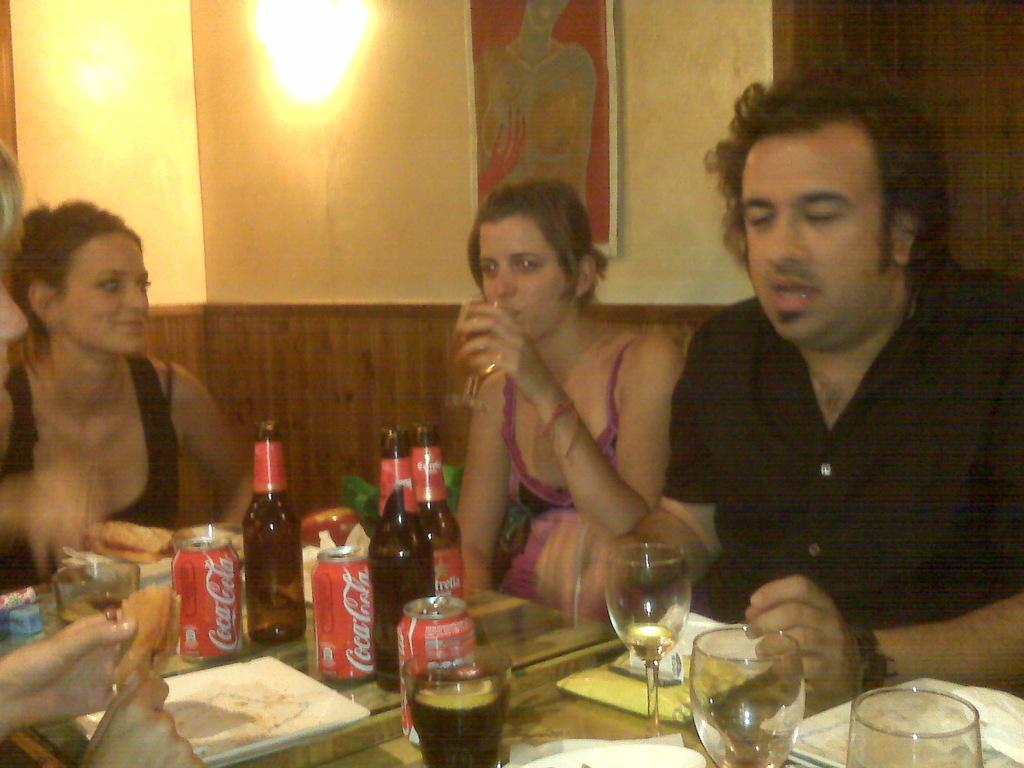Can you describe this image briefly? In this image I can see two women and a man wearing black colored dress are sitting in front of the table and on the table I can see few bottles, few glasses, few tens and few other objects. In the background I can see the wall, a photo frame attached to the wall and a light. 